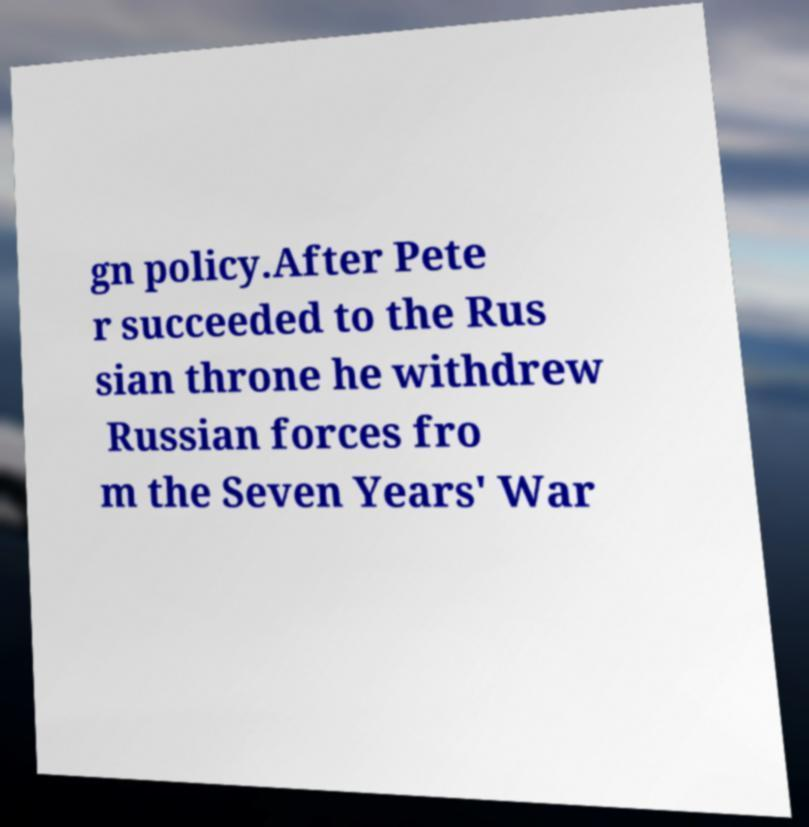There's text embedded in this image that I need extracted. Can you transcribe it verbatim? gn policy.After Pete r succeeded to the Rus sian throne he withdrew Russian forces fro m the Seven Years' War 